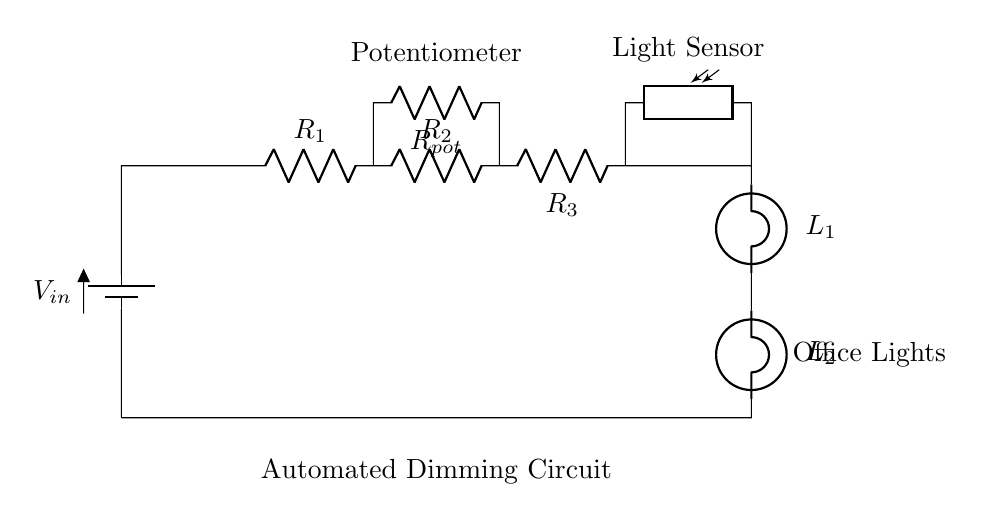What type of circuit is illustrated? This circuit is a series circuit where components are connected end-to-end, creating a single path for current to flow. All components, including resistors and bulbs, are in a linear arrangement without any branches.
Answer: Series What is the role of the potentiometer in this circuit? The potentiometer serves as a variable resistor, allowing the user to adjust the resistance and thus control the dimming level of the lights by varying the voltage dropped across it according to its position.
Answer: Dimming control How many bulbs are present in the circuit? The diagram includes two light bulbs labeled as L1 and L2, both connected in series as part of the lighting control system.
Answer: Two What is the function of the photoresistor? The photoresistor detects light levels in the environment, and changes its resistance accordingly, which influences the current passing through the circuit and contributes to the automatic dimming functionality.
Answer: Light detection If R1, R2, and R3 have values of 10 ohms each, what is the total resistance of the circuit? To find the total resistance in a series circuit, you add the resistance values together. The total resistance is 10 ohms + 10 ohms + 10 ohms = 30 ohms.
Answer: Thirty ohms What happens to the brightness of the bulbs when the light sensor detects more light? When more light is detected, the resistance of the photoresistor decreases, allowing more current to flow through the circuit, which increases the brightness of the bulbs.
Answer: Increases What kind of control system is represented by the circuit? The circuit represents an automated dimming control system for office spaces, designed to adjust light output based on ambient light conditions through the interaction between the potentiometer and photoresistor.
Answer: Automated dimming 